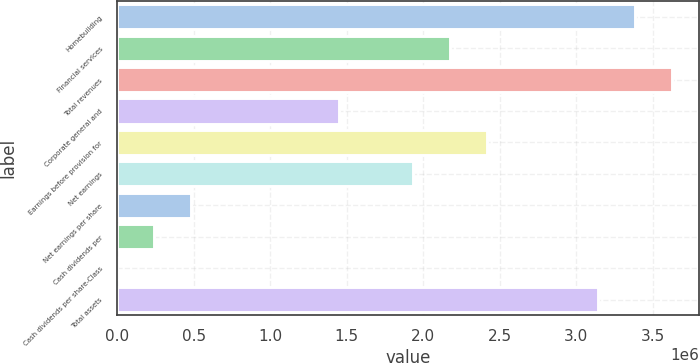<chart> <loc_0><loc_0><loc_500><loc_500><bar_chart><fcel>Homebuilding<fcel>Financial services<fcel>Total revenues<fcel>Corporate general and<fcel>Earnings before provision for<fcel>Net earnings<fcel>Net earnings per share<fcel>Cash dividends per<fcel>Cash dividends per share-Class<fcel>Total assets<nl><fcel>3.38361e+06<fcel>2.17518e+06<fcel>3.6253e+06<fcel>1.45012e+06<fcel>2.41687e+06<fcel>1.93349e+06<fcel>483373<fcel>241687<fcel>0.04<fcel>3.14192e+06<nl></chart> 